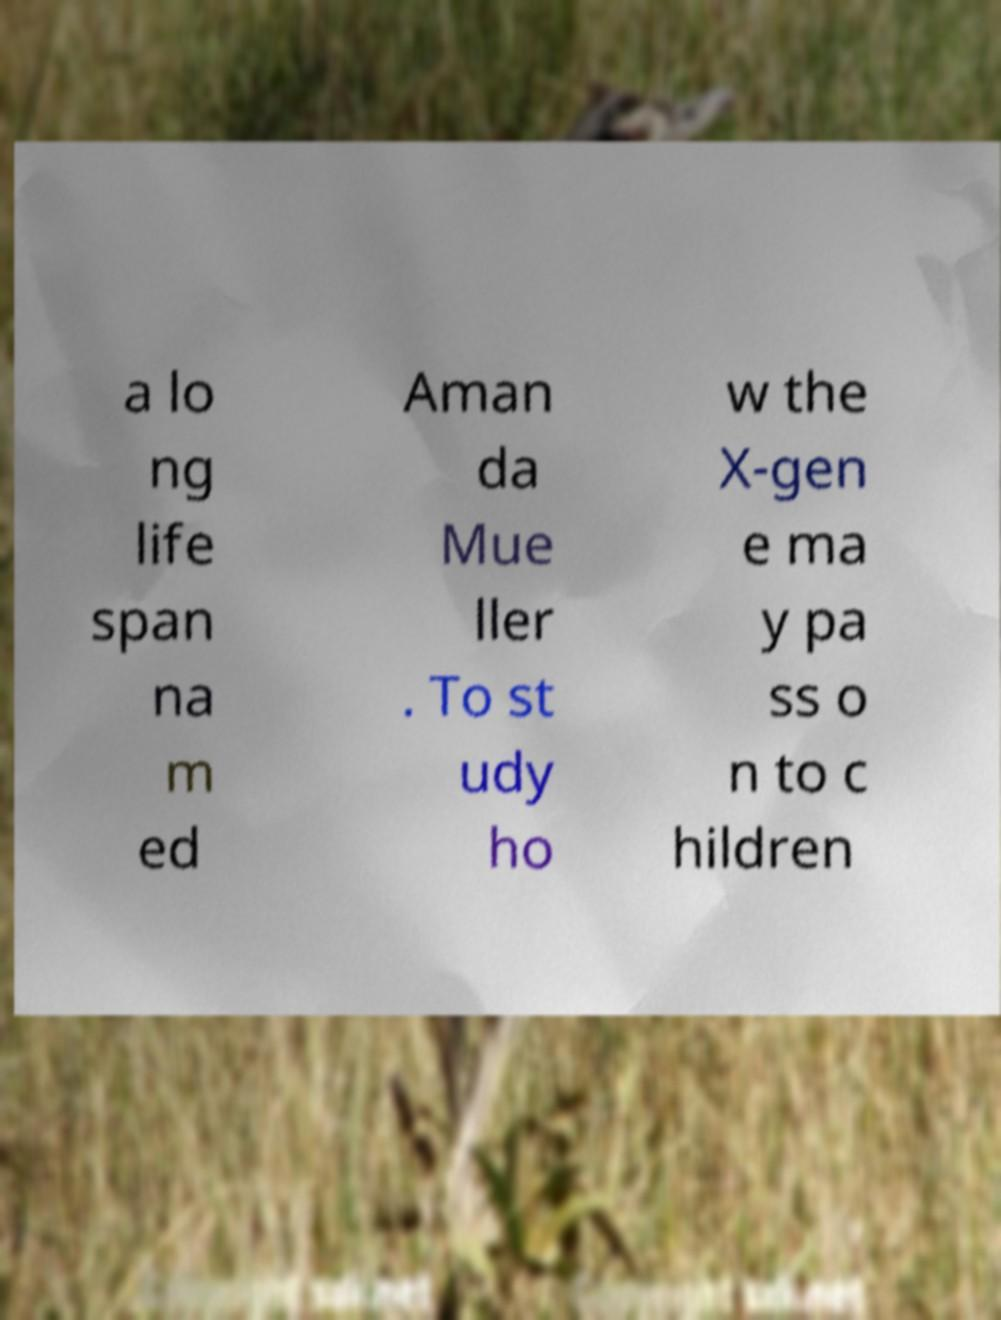Can you read and provide the text displayed in the image?This photo seems to have some interesting text. Can you extract and type it out for me? a lo ng life span na m ed Aman da Mue ller . To st udy ho w the X-gen e ma y pa ss o n to c hildren 